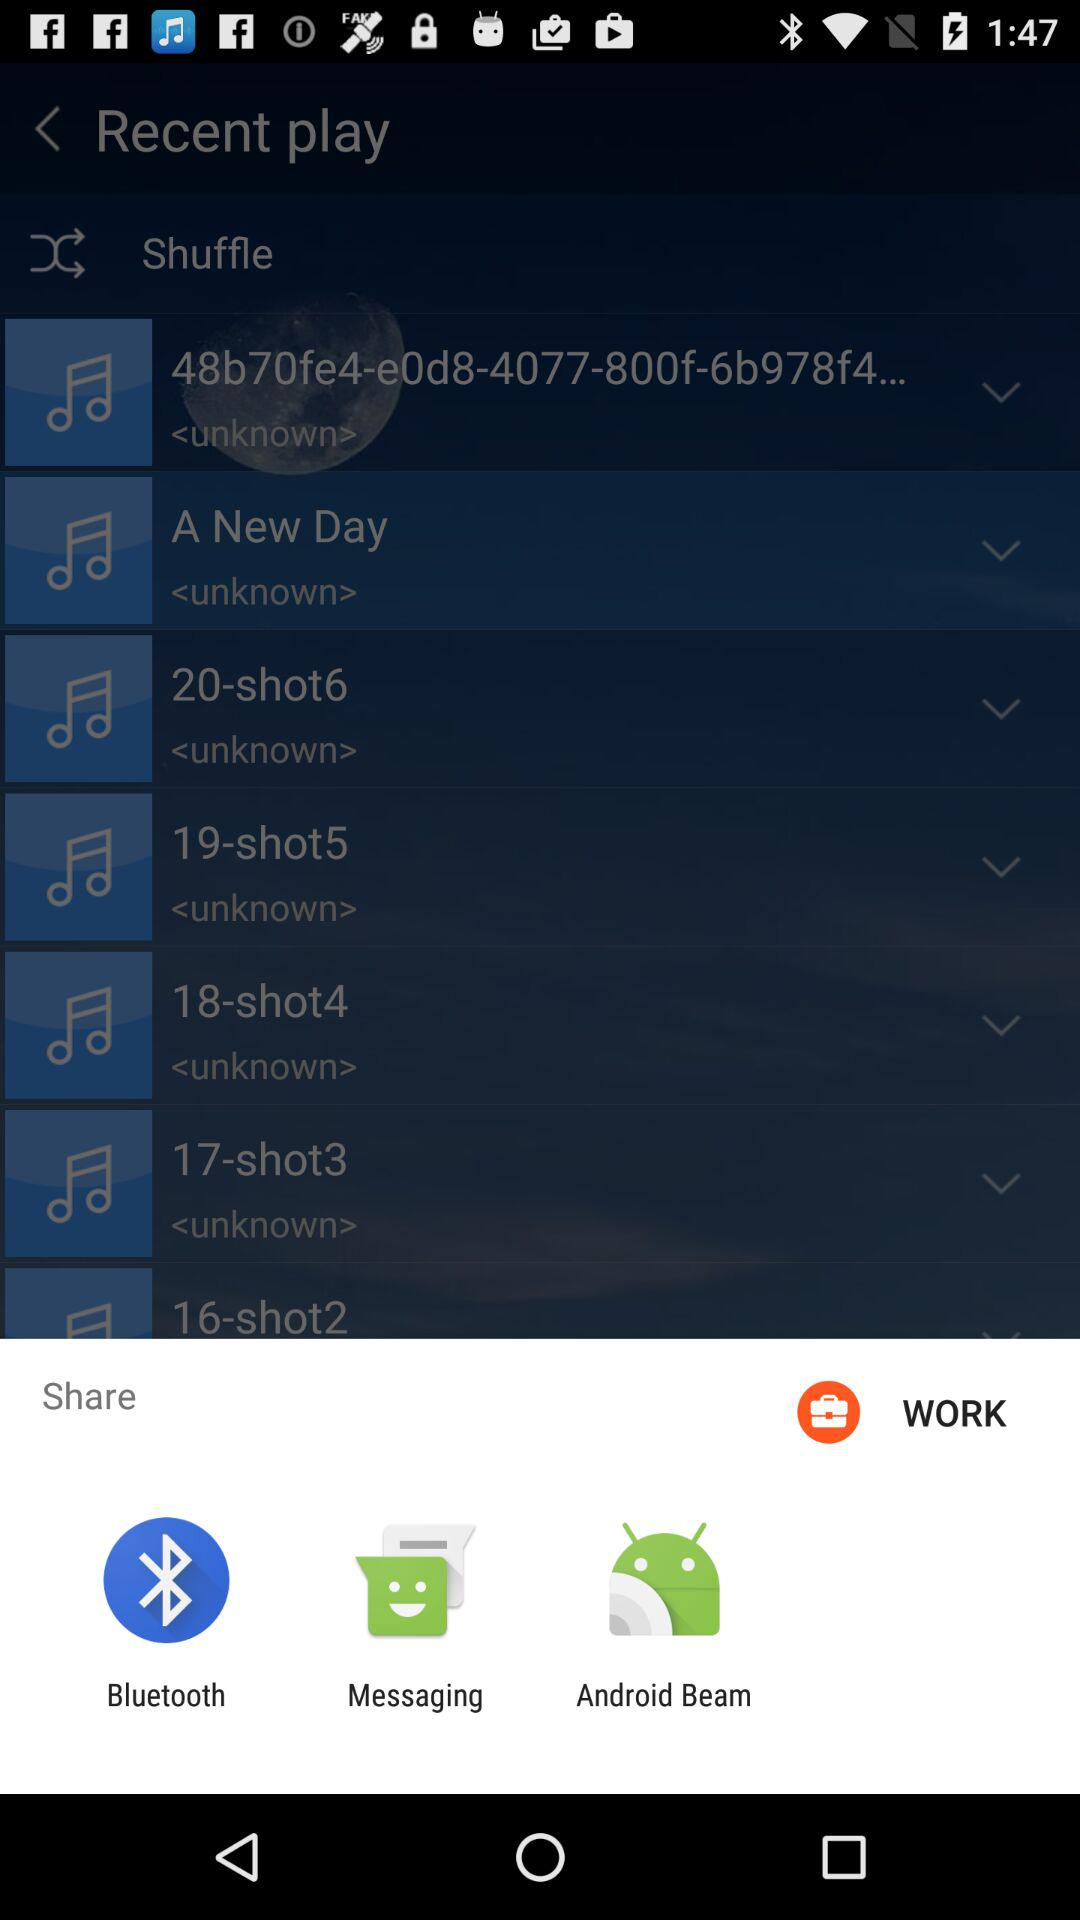What are the sharing options? The sharing options are "Bluetooth", "Messaging" and "Android Beam". 